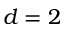Convert formula to latex. <formula><loc_0><loc_0><loc_500><loc_500>d = 2</formula> 